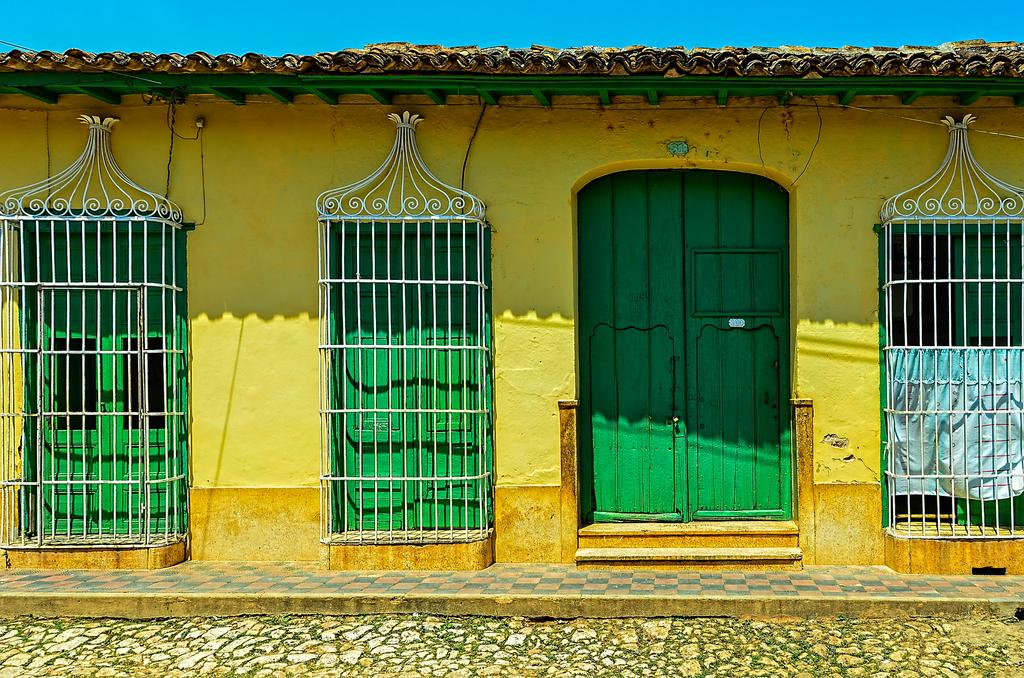What color is the wall in the image? The wall in the image is yellow. What color are the windows and doors in the image? The windows and doors in the image are green. What type of pathway is visible in the image? There is a stone walkway in the image. What color is the sky in the background of the image? The sky in the background of the image is blue. Can you hear the bell ringing in the park in the image? There is no bell or park present in the image; it only features a wall, windows, doors, a stone walkway, and the sky. 